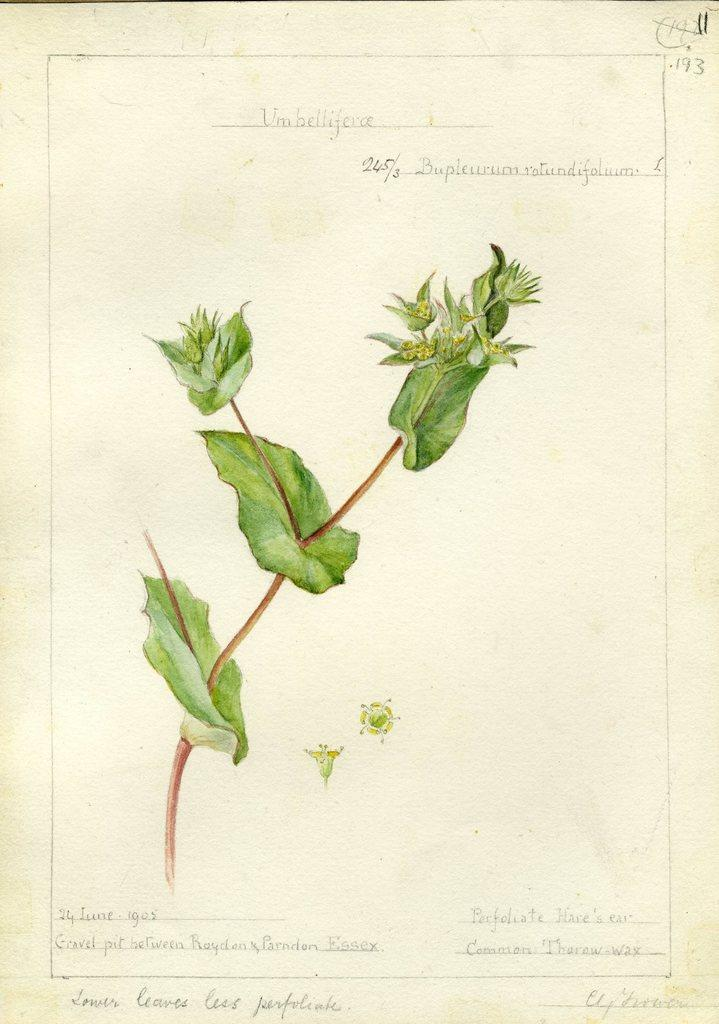What is featured in the image? There is a poster in the image. What can be found on the poster? The poster contains text and an image of a plant. What type of yarn is being used by the women in the image? There are no women or yarn present in the image; it only features a poster with text and an image of a plant. 